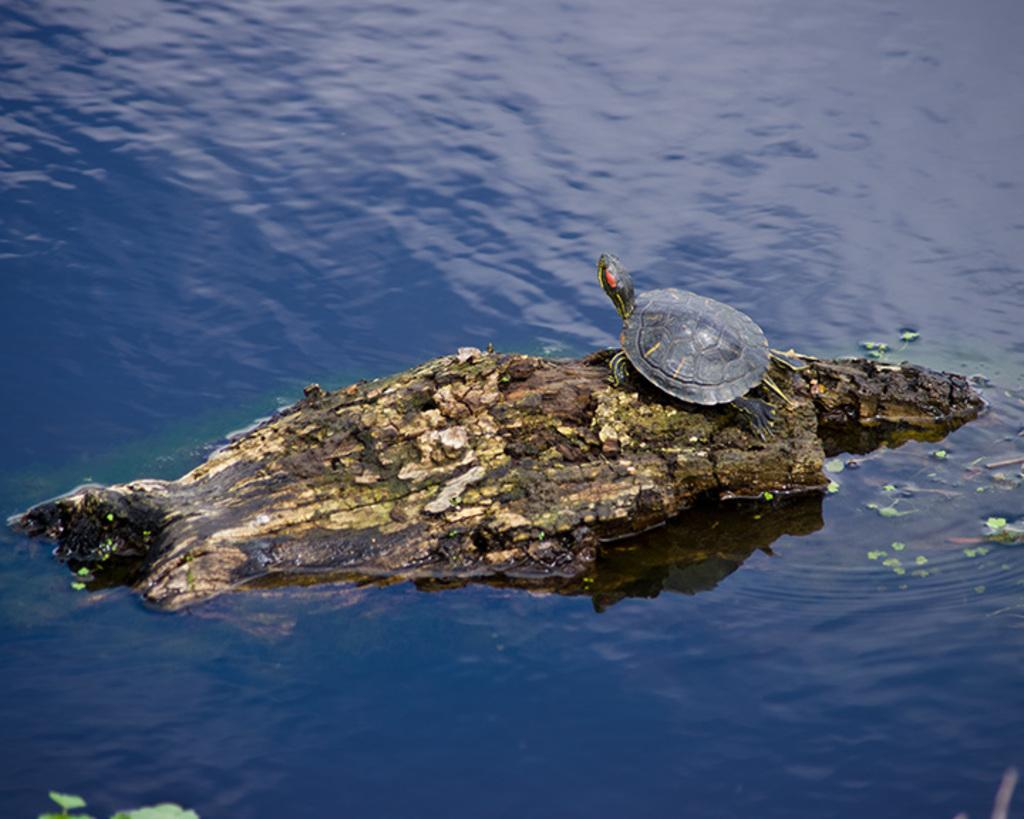What is the main object in the image? There is a piece of wood in the image. What is the condition of the wood in the image? The wood is floating on the water. What animal is present in the image? There is a tortoise in the image. How is the tortoise positioned in relation to the wood? The tortoise is standing on the wood. How many houses can be seen in the image? There are no houses present in the image. Who is the expert in the image? There is no expert present in the image. 